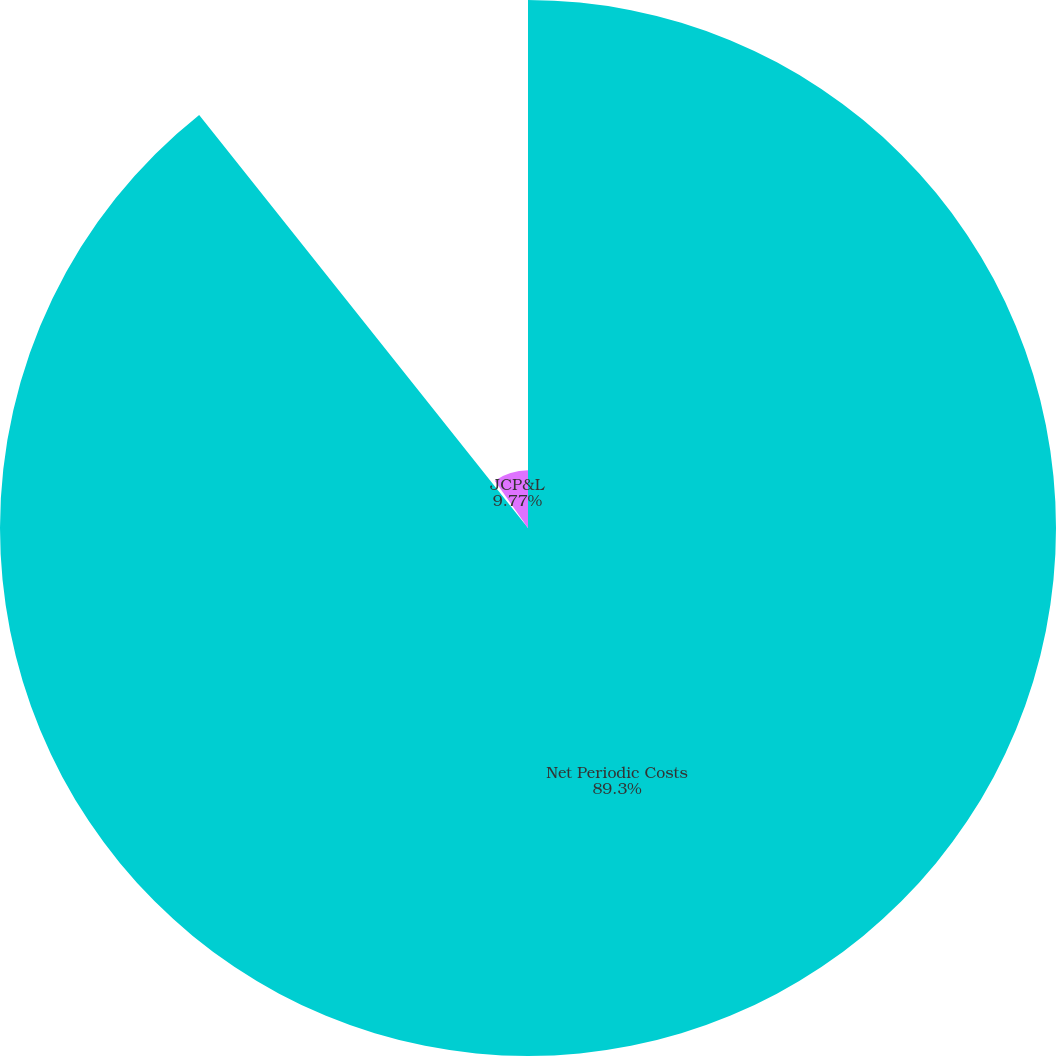<chart> <loc_0><loc_0><loc_500><loc_500><pie_chart><fcel>Net Periodic Costs<fcel>OE<fcel>JCP&L<nl><fcel>89.3%<fcel>0.93%<fcel>9.77%<nl></chart> 